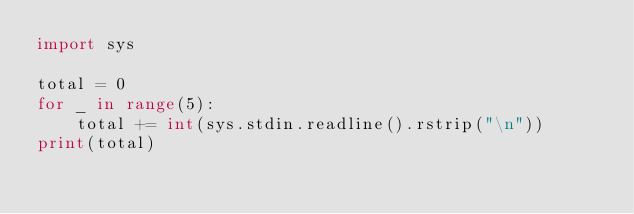<code> <loc_0><loc_0><loc_500><loc_500><_Python_>import sys

total = 0
for _ in range(5):
    total += int(sys.stdin.readline().rstrip("\n"))
print(total)</code> 